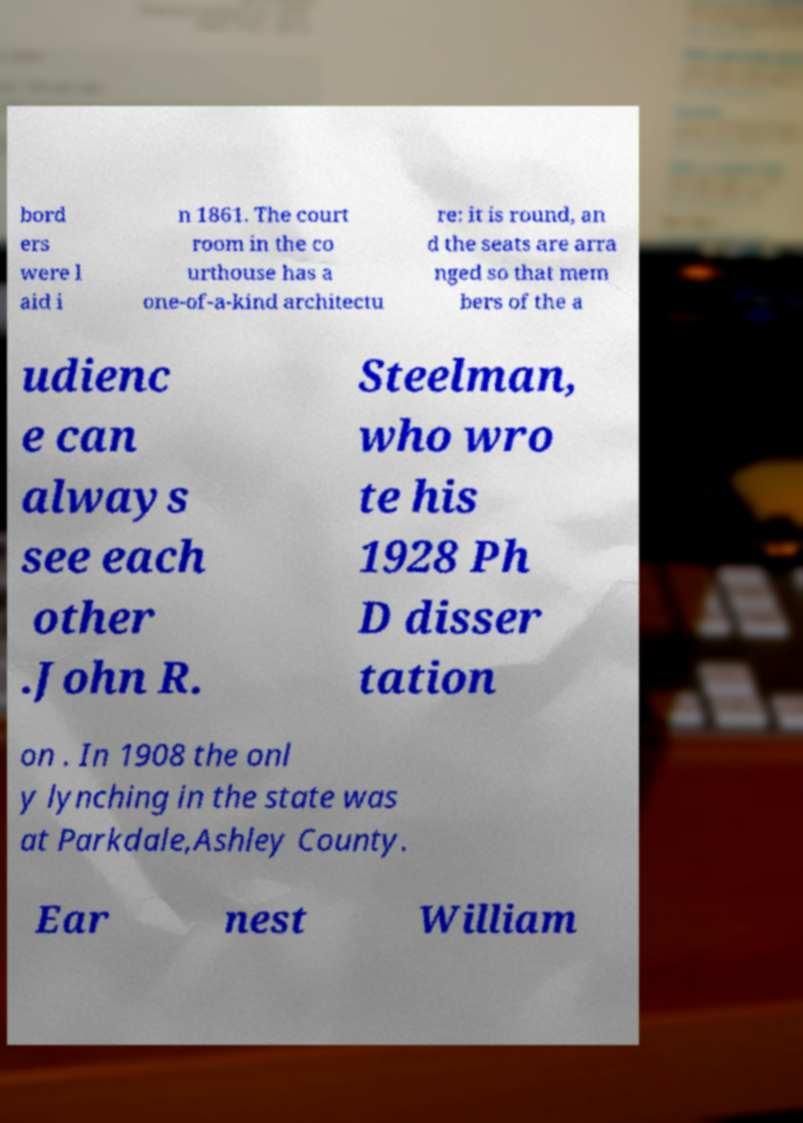There's text embedded in this image that I need extracted. Can you transcribe it verbatim? bord ers were l aid i n 1861. The court room in the co urthouse has a one-of-a-kind architectu re: it is round, an d the seats are arra nged so that mem bers of the a udienc e can always see each other .John R. Steelman, who wro te his 1928 Ph D disser tation on . In 1908 the onl y lynching in the state was at Parkdale,Ashley County. Ear nest William 